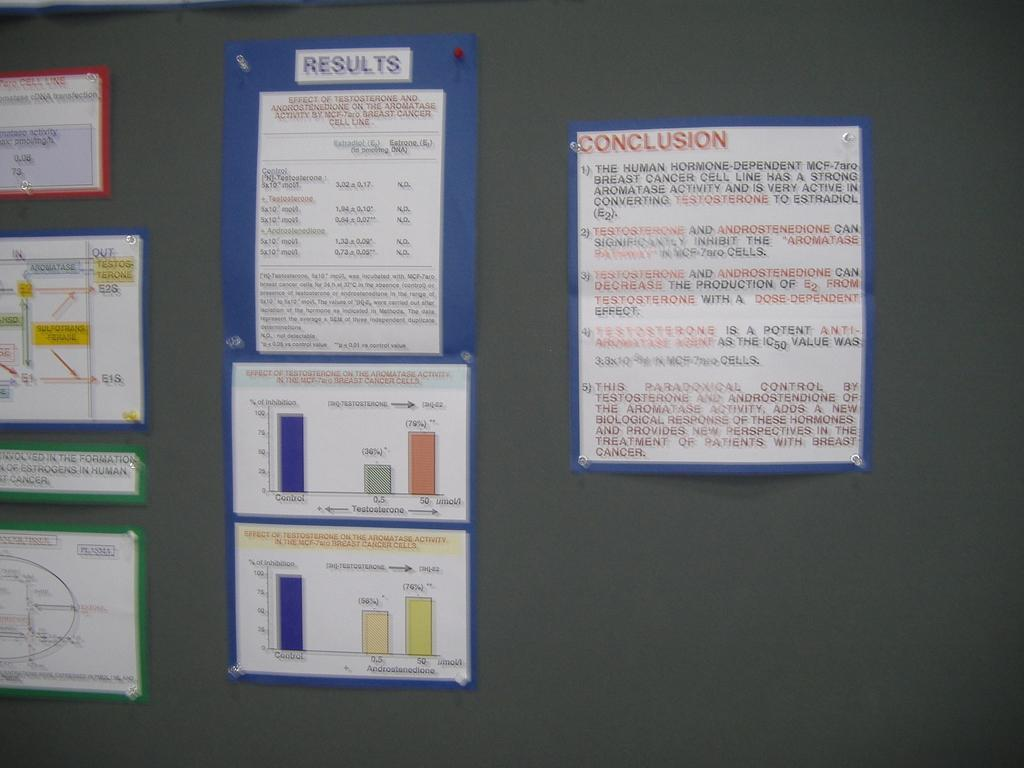<image>
Relay a brief, clear account of the picture shown. The papers are attached to a wall with results and conclusions on them. 